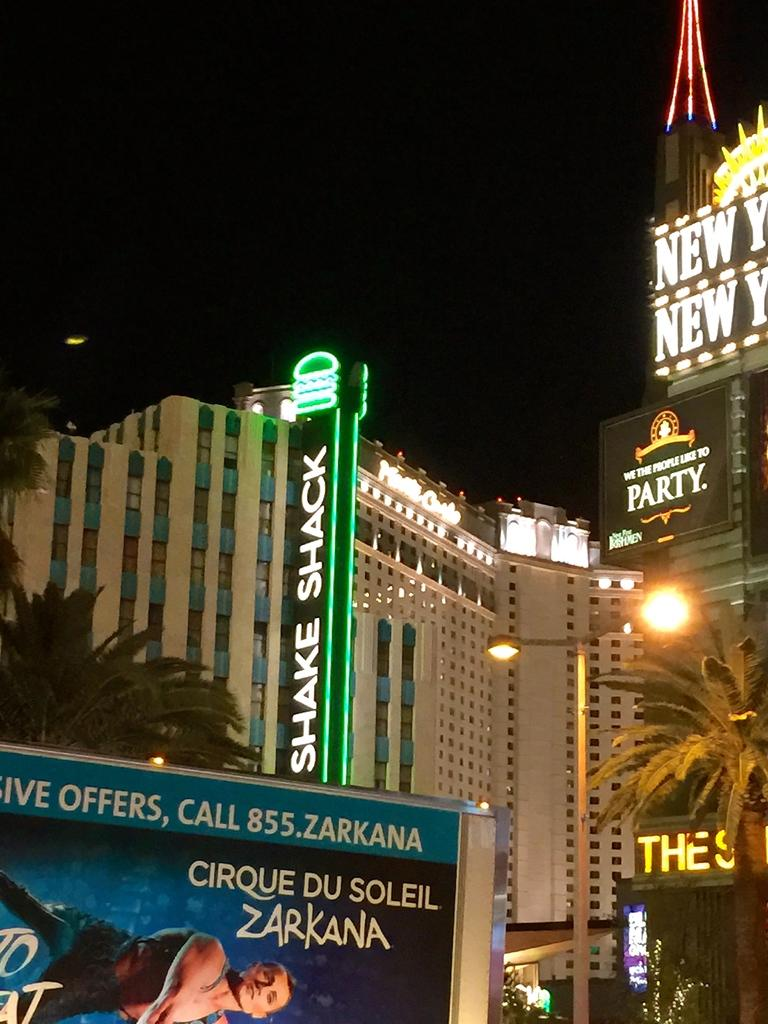What type of structures can be seen in the image? There are buildings in the image. What else is visible in the image besides the buildings? There are lights, trees, and a banner in the image. What is visible at the top of the image? The sky is visible at the top of the image. How would you describe the lighting in the image? The image is a little dark. Can you tell me how many dogs are depicted on the banner in the image? There are no dogs depicted on the banner or in the image. What type of agreement is being signed in the image? There is no agreement or signing activity present in the image. 